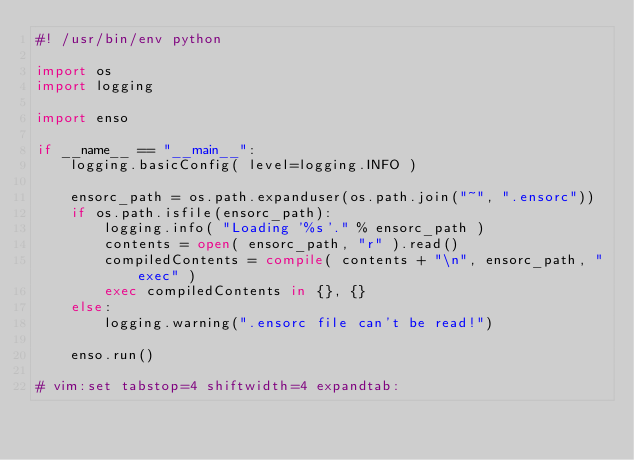<code> <loc_0><loc_0><loc_500><loc_500><_Python_>#! /usr/bin/env python

import os
import logging

import enso

if __name__ == "__main__":
    logging.basicConfig( level=logging.INFO )

    ensorc_path = os.path.expanduser(os.path.join("~", ".ensorc"))
    if os.path.isfile(ensorc_path):
        logging.info( "Loading '%s'." % ensorc_path )
        contents = open( ensorc_path, "r" ).read()
        compiledContents = compile( contents + "\n", ensorc_path, "exec" )
        exec compiledContents in {}, {}
    else:
        logging.warning(".ensorc file can't be read!")

    enso.run()

# vim:set tabstop=4 shiftwidth=4 expandtab:
</code> 